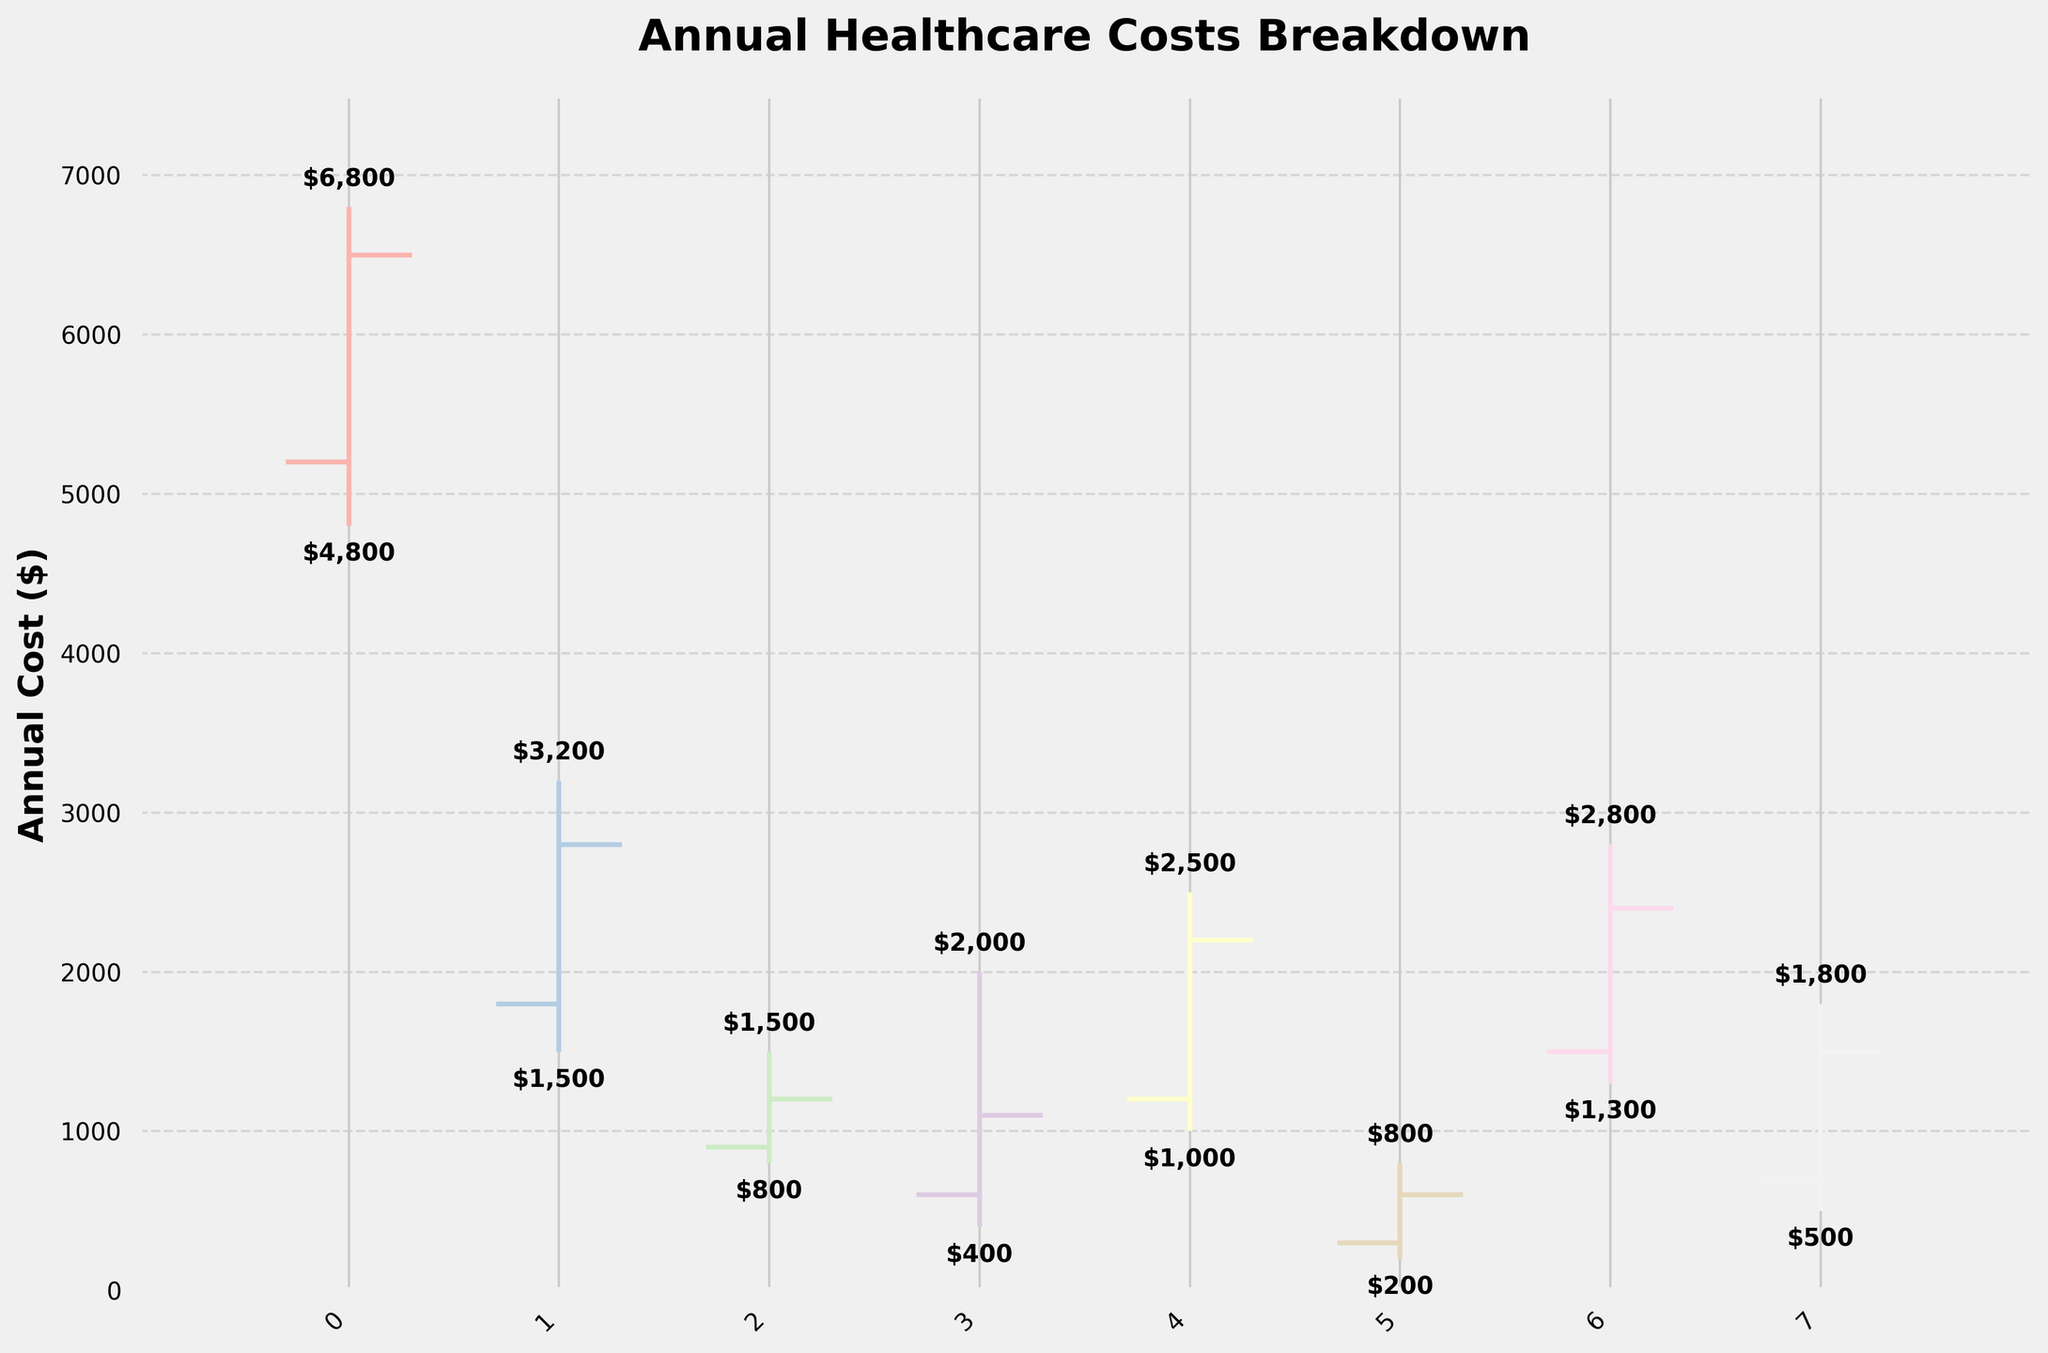What is the highest annual cost for insurance premiums? To find the highest annual cost for insurance premiums, look at the "High" value for that category in the OHLC chart. The "High" value for insurance premiums is $6800.
Answer: $6800 Which category has the lowest annual cost? To find the category with the lowest annual cost, refer to the "Low" values across all categories in the chart and identify the minimum value. The lowest annual cost is for medical equipment with a "Low" value of $200.
Answer: Medical Equipment What's the total annual cost at the closing value for prescriptions and emergency care? To find the total annual cost at the closing value for prescriptions and emergency care, sum their "Close" values. For prescriptions, the "Close" value is $1200. For emergency care, it is $1100. Sum these values: $1200 + $1100 = $2300.
Answer: $2300 Which category has the largest difference between its high and low values? To determine this, calculate the difference between the "High" and "Low" values for each category and identify the largest one. Emergency care has a "High" of $2000 and a "Low" of $400, giving a difference of $1600, which is the largest.
Answer: Emergency Care What is the average opening cost of all categories combined? First, sum the "Open" values of all categories and then divide by the number of categories. The open values are: $5200, $1800, $900, $600, $1200, $300, $1500, $700. Sum: $5200 + $1800 + $900 + $600 + $1200 + $300 + $1500 + $700 = $12,200. Since there are 8 categories, the average is $12,200 / 8 = $1525.
Answer: $1525 Which category has a higher closing value, insurance premiums or therapy sessions? Compare the "Close" values of insurance premiums and therapy sessions. Insurance premiums have a "Close" value of $6500, while therapy sessions have a "Close" value of $2400. Insurance premiums have a higher closing value.
Answer: Insurance Premiums Is the closing value for diagnostic tests less than the opening value? Compare the "Close" value of diagnostic tests ($1500) with its "Open" value ($700). Since $700 is less than $1500, the closing value is higher than the opening value.
Answer: No What is the range of opening values across all categories? To determine the range, subtract the smallest "Open" value from the largest "Open" value. The smallest "Open" value is $300 (medical equipment) and the largest is $5200 (insurance premiums). The range is $5200 - $300 = $4900.
Answer: $4900 How much more is the high value for specialist visits compared to prescriptions? Compare the "High" values of specialist visits ($2500) and prescriptions ($1500). Subtract the high value of prescriptions from that of specialist visits: $2500 - $1500 = $1000.
Answer: $1000 